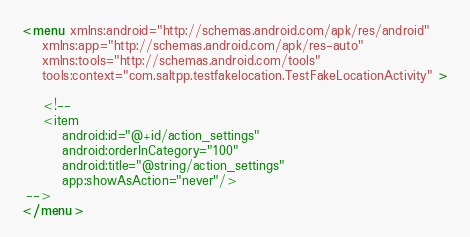<code> <loc_0><loc_0><loc_500><loc_500><_XML_><menu xmlns:android="http://schemas.android.com/apk/res/android"
    xmlns:app="http://schemas.android.com/apk/res-auto"
    xmlns:tools="http://schemas.android.com/tools"
    tools:context="com.saltpp.testfakelocation.TestFakeLocationActivity" >

    <!-- 
    <item
        android:id="@+id/action_settings"
        android:orderInCategory="100"
        android:title="@string/action_settings"
        app:showAsAction="never"/>
 -->
</menu>
</code> 